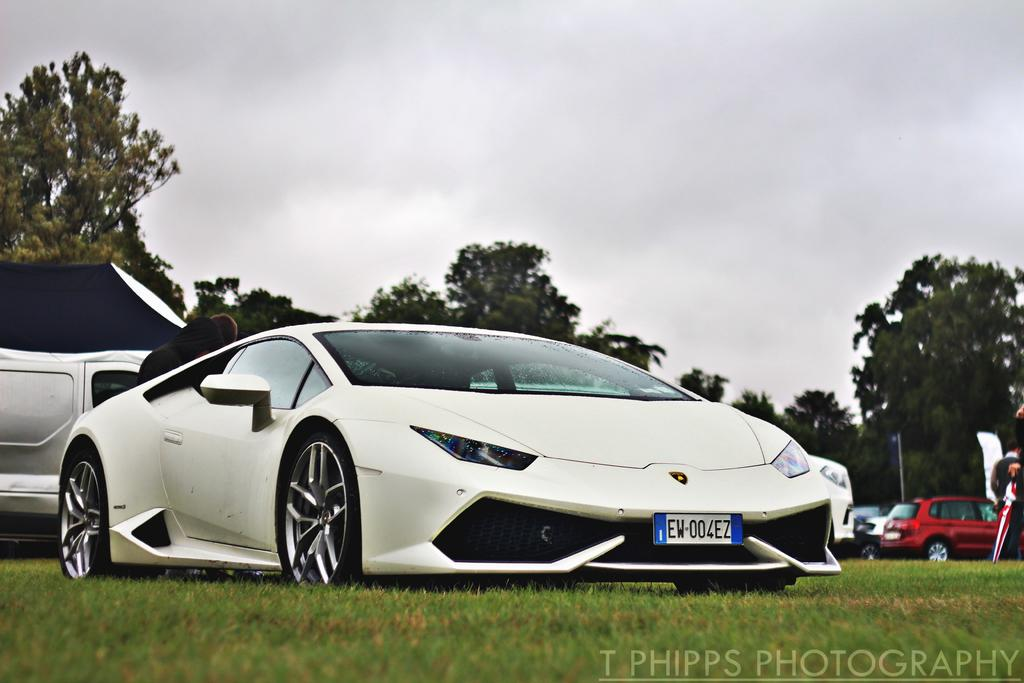What types of vehicles can be seen in the image? There are vehicles of different colors in the image. What natural elements are visible in the image? Grass and trees are visible in the image. What additional feature can be found in the image? There is a watermark in the image. How would you describe the sky in the image? The sky is cloudy in the image. What type of grape is being used to clean the vehicles in the image? There is no grape present in the image, and grapes are not used for cleaning vehicles. 